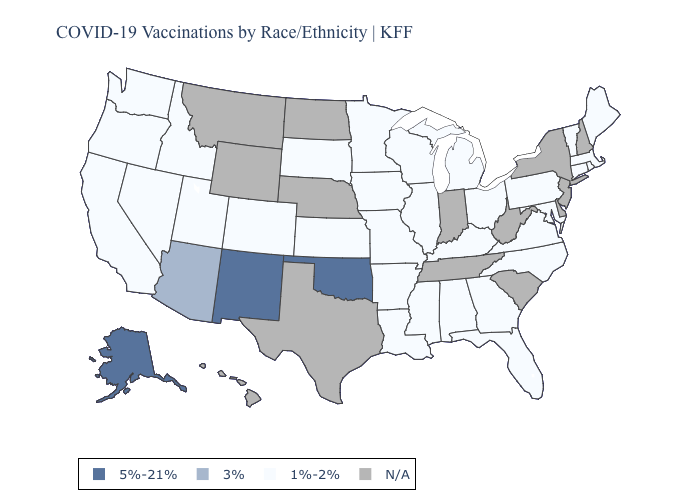What is the value of Minnesota?
Be succinct. 1%-2%. Name the states that have a value in the range 3%?
Short answer required. Arizona. Which states have the highest value in the USA?
Be succinct. Alaska, New Mexico, Oklahoma. Name the states that have a value in the range N/A?
Answer briefly. Delaware, Hawaii, Indiana, Montana, Nebraska, New Hampshire, New Jersey, New York, North Dakota, South Carolina, Tennessee, Texas, West Virginia, Wyoming. What is the value of Minnesota?
Give a very brief answer. 1%-2%. Which states have the lowest value in the South?
Keep it brief. Alabama, Arkansas, Florida, Georgia, Kentucky, Louisiana, Maryland, Mississippi, North Carolina, Virginia. Does Wisconsin have the highest value in the USA?
Keep it brief. No. What is the value of Tennessee?
Be succinct. N/A. Name the states that have a value in the range 3%?
Write a very short answer. Arizona. What is the value of Delaware?
Answer briefly. N/A. What is the value of Tennessee?
Short answer required. N/A. Among the states that border Arizona , which have the lowest value?
Give a very brief answer. California, Colorado, Nevada, Utah. Does Alaska have the lowest value in the USA?
Write a very short answer. No. Name the states that have a value in the range 1%-2%?
Keep it brief. Alabama, Arkansas, California, Colorado, Connecticut, Florida, Georgia, Idaho, Illinois, Iowa, Kansas, Kentucky, Louisiana, Maine, Maryland, Massachusetts, Michigan, Minnesota, Mississippi, Missouri, Nevada, North Carolina, Ohio, Oregon, Pennsylvania, Rhode Island, South Dakota, Utah, Vermont, Virginia, Washington, Wisconsin. What is the value of Tennessee?
Be succinct. N/A. 